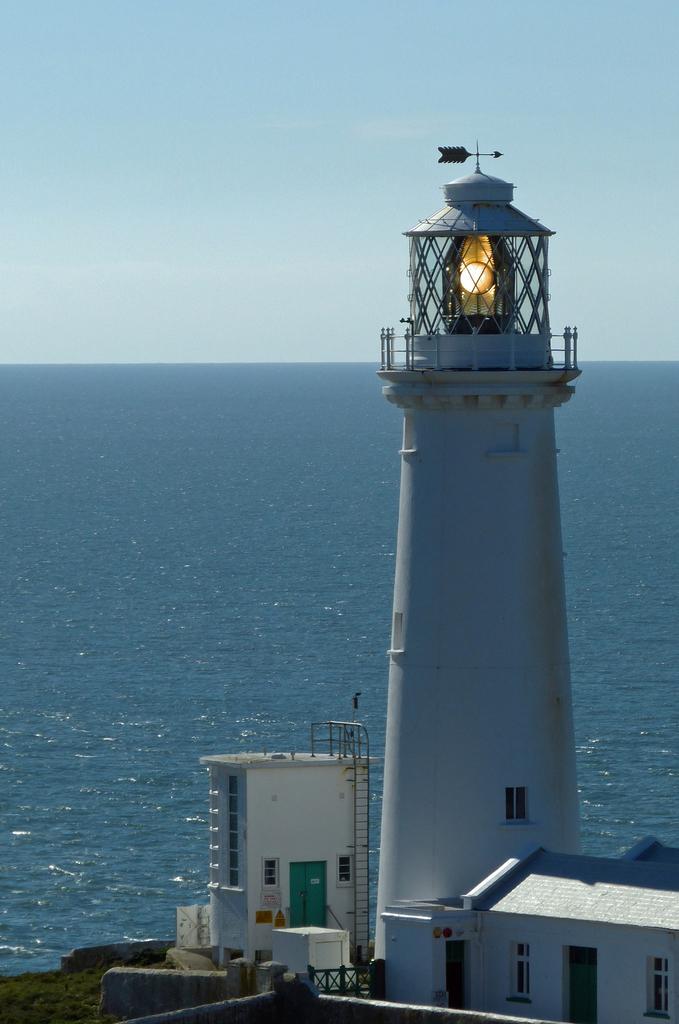Can you describe this image briefly? In this image I can see a white color light house. I can see buildings,windows,ladder and water. The sky is in white and blue color. 